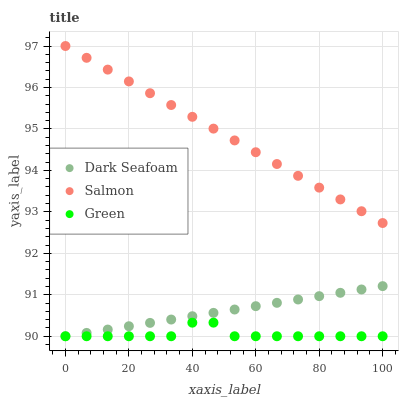Does Green have the minimum area under the curve?
Answer yes or no. Yes. Does Salmon have the maximum area under the curve?
Answer yes or no. Yes. Does Dark Seafoam have the minimum area under the curve?
Answer yes or no. No. Does Dark Seafoam have the maximum area under the curve?
Answer yes or no. No. Is Dark Seafoam the smoothest?
Answer yes or no. Yes. Is Green the roughest?
Answer yes or no. Yes. Is Salmon the smoothest?
Answer yes or no. No. Is Salmon the roughest?
Answer yes or no. No. Does Green have the lowest value?
Answer yes or no. Yes. Does Salmon have the lowest value?
Answer yes or no. No. Does Salmon have the highest value?
Answer yes or no. Yes. Does Dark Seafoam have the highest value?
Answer yes or no. No. Is Dark Seafoam less than Salmon?
Answer yes or no. Yes. Is Salmon greater than Dark Seafoam?
Answer yes or no. Yes. Does Dark Seafoam intersect Green?
Answer yes or no. Yes. Is Dark Seafoam less than Green?
Answer yes or no. No. Is Dark Seafoam greater than Green?
Answer yes or no. No. Does Dark Seafoam intersect Salmon?
Answer yes or no. No. 